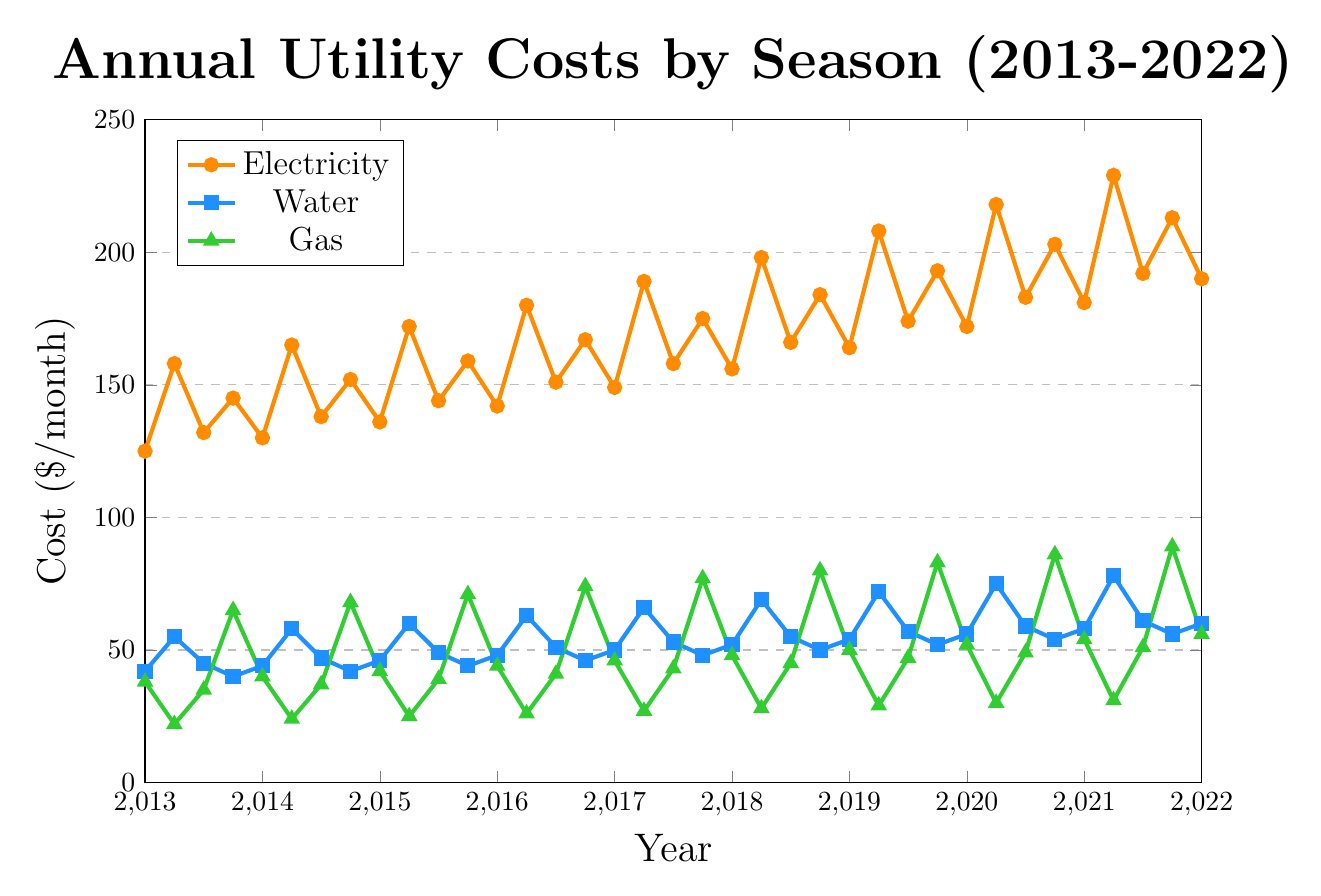What was the cost of electricity in Summer 2022? In Summer 2022, the cost of electricity can be read directly from the electricity line, marked with a specific color. Locate the 2022 point on the x-axis and follow it up to the corresponding value on the electricity line.
Answer: 240 How did the cost of gas in Winter 2015 compare to Spring 2015? To determine the comparison, locate both Winter 2015 and Spring 2015 on the x-axis, identify their respective gas costs, and then compare them. Winter 2015 gas cost was 71, and Spring 2015 gas cost was 42.
Answer: Winter 2015 > Spring 2015 Which season had the highest water cost in 2019? To find this, check all 2019 points and look at the water costs for each season. Summer 2019 had the highest water cost of 72.
Answer: Summer What is the overall trend in electricity costs from 2013 to 2022? To determine the trend, observe the general direction of the electricity cost line from 2013 to 2022. The line shows an upward trend over the decade.
Answer: Rising Calculate the average gas cost during Winter seasons over the decade. Identify the gas costs for Winter in each year, sum them up, and then divide by the number of Winter seasons (10). (65 + 68 + 71 + 74 + 77 + 80 + 83 + 86 + 89 + 92) / 10 = 78.5
Answer: 78.5 Did water cost more in Summer 2017 or Fall 2017? Compare the water costs in Summer 2017 and Fall 2017 by locating each season's data point and reading the values. Summer 2017 had 66, while Fall 2017 had 53.
Answer: Summer 2017 Describe how the visual colors help differentiate between electricity, water, and gas costs in the figure. The colors are distinct and aid in distinguishing the different utilities. Electricity costs are indicated with orange, water with blue, and gas with green, making it easy to differentiate between the lines visually.
Answer: Different colors Between 2018 and 2020, which season saw the largest increase in electricity costs? To find this, calculate the change in electricity costs for each season between 2018 and 2020 and identify the largest increase. Summer saw the largest increase from 198 to 218, a change of 20.
Answer: Summer What was the pattern of gas cost changes in Spring from 2013 to 2022? Check the gas cost values for Spring each year, noticing an upward trend from 38 in 2013 to 56 in 2022, showing a general incremental pattern.
Answer: Increasing How did the cost of water evolve from Winter 2013 to Winter 2022? Assess the water cost data points for each Winter, starting from 40 in 2013 to 58 in 2022, noting the overall trend and any fluctuations. The overall trend indicates an increase despite some minor fluctuations.
Answer: Increased 